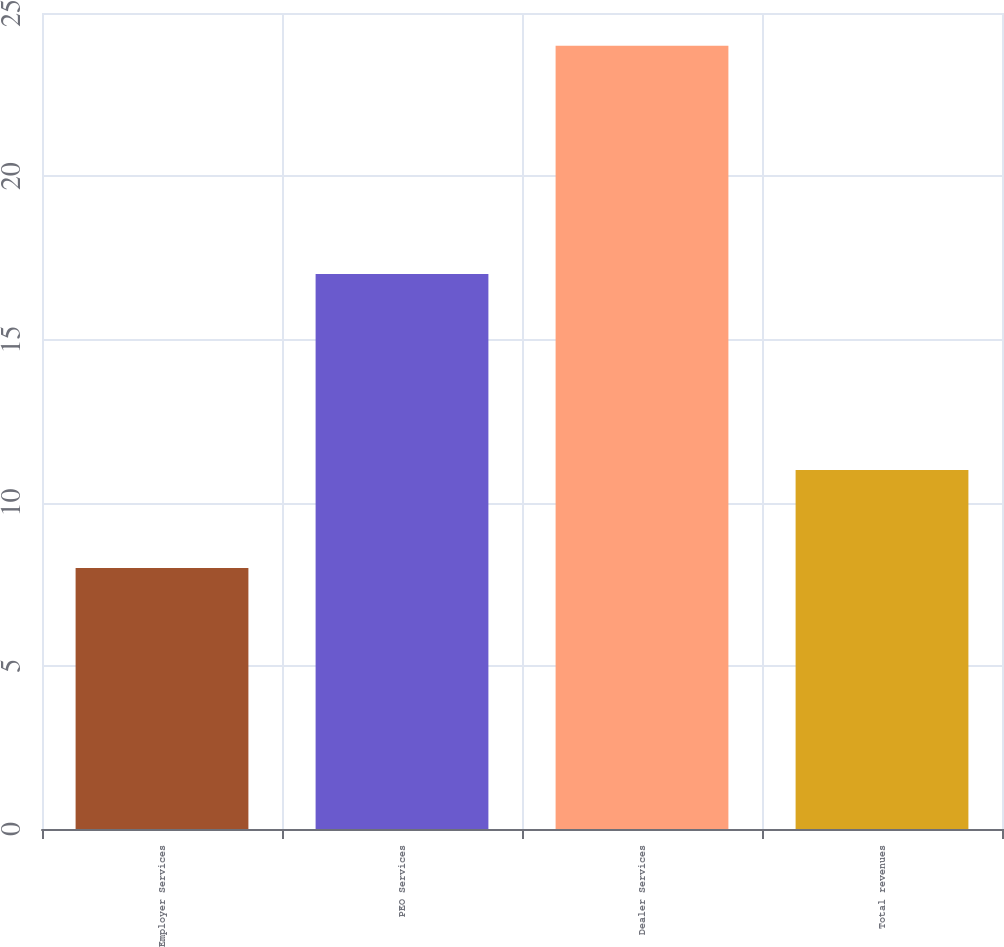<chart> <loc_0><loc_0><loc_500><loc_500><bar_chart><fcel>Employer Services<fcel>PEO Services<fcel>Dealer Services<fcel>Total revenues<nl><fcel>8<fcel>17<fcel>24<fcel>11<nl></chart> 